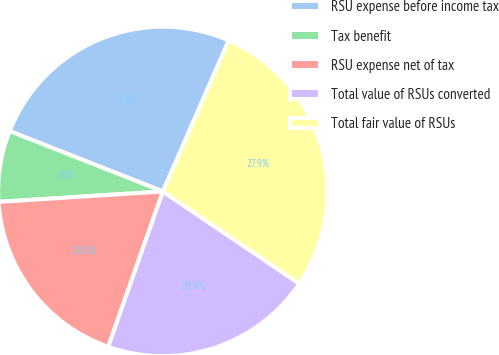<chart> <loc_0><loc_0><loc_500><loc_500><pie_chart><fcel>RSU expense before income tax<fcel>Tax benefit<fcel>RSU expense net of tax<fcel>Total value of RSUs converted<fcel>Total fair value of RSUs<nl><fcel>25.58%<fcel>6.98%<fcel>18.6%<fcel>20.93%<fcel>27.91%<nl></chart> 